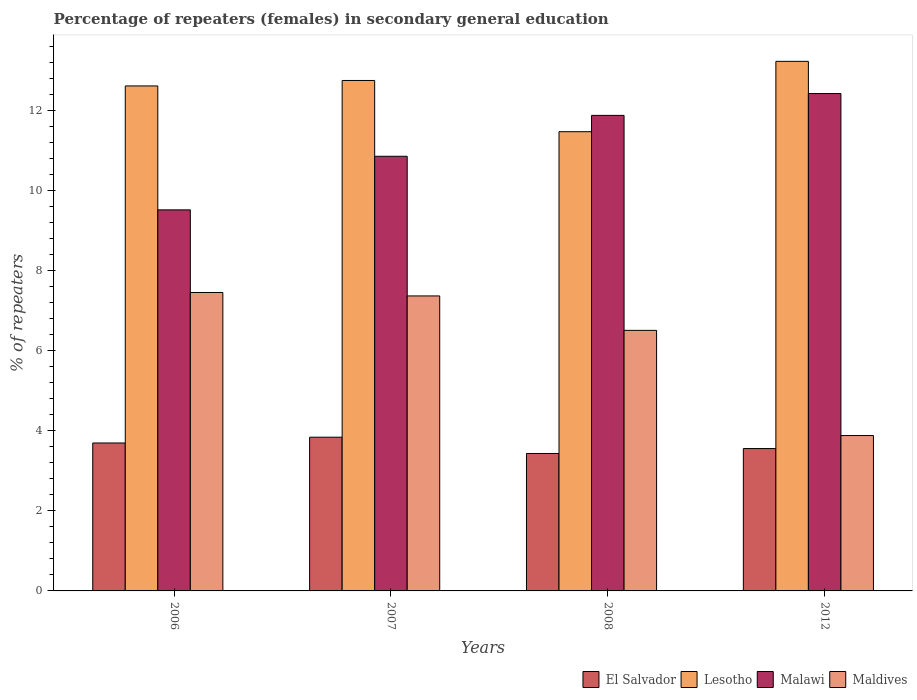How many different coloured bars are there?
Offer a very short reply. 4. How many bars are there on the 3rd tick from the left?
Make the answer very short. 4. How many bars are there on the 1st tick from the right?
Keep it short and to the point. 4. What is the label of the 2nd group of bars from the left?
Offer a very short reply. 2007. What is the percentage of female repeaters in Lesotho in 2012?
Give a very brief answer. 13.23. Across all years, what is the maximum percentage of female repeaters in El Salvador?
Provide a succinct answer. 3.84. Across all years, what is the minimum percentage of female repeaters in Malawi?
Ensure brevity in your answer.  9.52. In which year was the percentage of female repeaters in Lesotho maximum?
Offer a very short reply. 2012. In which year was the percentage of female repeaters in Maldives minimum?
Ensure brevity in your answer.  2012. What is the total percentage of female repeaters in Maldives in the graph?
Offer a very short reply. 25.23. What is the difference between the percentage of female repeaters in El Salvador in 2007 and that in 2012?
Your answer should be very brief. 0.28. What is the difference between the percentage of female repeaters in Lesotho in 2006 and the percentage of female repeaters in Maldives in 2012?
Offer a terse response. 8.74. What is the average percentage of female repeaters in Malawi per year?
Offer a very short reply. 11.18. In the year 2007, what is the difference between the percentage of female repeaters in Lesotho and percentage of female repeaters in El Salvador?
Offer a terse response. 8.91. In how many years, is the percentage of female repeaters in Lesotho greater than 0.8 %?
Provide a succinct answer. 4. What is the ratio of the percentage of female repeaters in Lesotho in 2006 to that in 2007?
Your response must be concise. 0.99. Is the difference between the percentage of female repeaters in Lesotho in 2006 and 2012 greater than the difference between the percentage of female repeaters in El Salvador in 2006 and 2012?
Offer a terse response. No. What is the difference between the highest and the second highest percentage of female repeaters in El Salvador?
Make the answer very short. 0.14. What is the difference between the highest and the lowest percentage of female repeaters in Lesotho?
Offer a very short reply. 1.76. In how many years, is the percentage of female repeaters in Lesotho greater than the average percentage of female repeaters in Lesotho taken over all years?
Ensure brevity in your answer.  3. Is it the case that in every year, the sum of the percentage of female repeaters in Maldives and percentage of female repeaters in El Salvador is greater than the sum of percentage of female repeaters in Lesotho and percentage of female repeaters in Malawi?
Your answer should be compact. Yes. What does the 3rd bar from the left in 2006 represents?
Provide a short and direct response. Malawi. What does the 2nd bar from the right in 2012 represents?
Ensure brevity in your answer.  Malawi. Is it the case that in every year, the sum of the percentage of female repeaters in Lesotho and percentage of female repeaters in Maldives is greater than the percentage of female repeaters in El Salvador?
Keep it short and to the point. Yes. How many years are there in the graph?
Keep it short and to the point. 4. Are the values on the major ticks of Y-axis written in scientific E-notation?
Offer a terse response. No. Does the graph contain any zero values?
Give a very brief answer. No. Where does the legend appear in the graph?
Your answer should be very brief. Bottom right. What is the title of the graph?
Provide a succinct answer. Percentage of repeaters (females) in secondary general education. What is the label or title of the Y-axis?
Keep it short and to the point. % of repeaters. What is the % of repeaters in El Salvador in 2006?
Make the answer very short. 3.7. What is the % of repeaters of Lesotho in 2006?
Make the answer very short. 12.62. What is the % of repeaters of Malawi in 2006?
Your answer should be compact. 9.52. What is the % of repeaters of Maldives in 2006?
Provide a short and direct response. 7.46. What is the % of repeaters in El Salvador in 2007?
Make the answer very short. 3.84. What is the % of repeaters in Lesotho in 2007?
Offer a very short reply. 12.76. What is the % of repeaters in Malawi in 2007?
Provide a short and direct response. 10.86. What is the % of repeaters of Maldives in 2007?
Give a very brief answer. 7.37. What is the % of repeaters in El Salvador in 2008?
Provide a short and direct response. 3.44. What is the % of repeaters in Lesotho in 2008?
Your answer should be compact. 11.48. What is the % of repeaters of Malawi in 2008?
Give a very brief answer. 11.88. What is the % of repeaters of Maldives in 2008?
Keep it short and to the point. 6.51. What is the % of repeaters in El Salvador in 2012?
Your answer should be compact. 3.56. What is the % of repeaters in Lesotho in 2012?
Ensure brevity in your answer.  13.23. What is the % of repeaters of Malawi in 2012?
Ensure brevity in your answer.  12.43. What is the % of repeaters of Maldives in 2012?
Your answer should be compact. 3.88. Across all years, what is the maximum % of repeaters of El Salvador?
Your answer should be compact. 3.84. Across all years, what is the maximum % of repeaters in Lesotho?
Provide a succinct answer. 13.23. Across all years, what is the maximum % of repeaters in Malawi?
Provide a succinct answer. 12.43. Across all years, what is the maximum % of repeaters of Maldives?
Give a very brief answer. 7.46. Across all years, what is the minimum % of repeaters of El Salvador?
Offer a terse response. 3.44. Across all years, what is the minimum % of repeaters in Lesotho?
Provide a succinct answer. 11.48. Across all years, what is the minimum % of repeaters of Malawi?
Provide a short and direct response. 9.52. Across all years, what is the minimum % of repeaters of Maldives?
Offer a very short reply. 3.88. What is the total % of repeaters of El Salvador in the graph?
Offer a very short reply. 14.53. What is the total % of repeaters in Lesotho in the graph?
Keep it short and to the point. 50.09. What is the total % of repeaters of Malawi in the graph?
Provide a succinct answer. 44.7. What is the total % of repeaters of Maldives in the graph?
Keep it short and to the point. 25.23. What is the difference between the % of repeaters in El Salvador in 2006 and that in 2007?
Give a very brief answer. -0.14. What is the difference between the % of repeaters in Lesotho in 2006 and that in 2007?
Offer a very short reply. -0.14. What is the difference between the % of repeaters of Malawi in 2006 and that in 2007?
Ensure brevity in your answer.  -1.34. What is the difference between the % of repeaters in Maldives in 2006 and that in 2007?
Provide a short and direct response. 0.09. What is the difference between the % of repeaters of El Salvador in 2006 and that in 2008?
Offer a terse response. 0.26. What is the difference between the % of repeaters of Lesotho in 2006 and that in 2008?
Make the answer very short. 1.14. What is the difference between the % of repeaters in Malawi in 2006 and that in 2008?
Give a very brief answer. -2.36. What is the difference between the % of repeaters in Maldives in 2006 and that in 2008?
Make the answer very short. 0.95. What is the difference between the % of repeaters of El Salvador in 2006 and that in 2012?
Your response must be concise. 0.14. What is the difference between the % of repeaters in Lesotho in 2006 and that in 2012?
Provide a short and direct response. -0.61. What is the difference between the % of repeaters of Malawi in 2006 and that in 2012?
Provide a succinct answer. -2.91. What is the difference between the % of repeaters of Maldives in 2006 and that in 2012?
Make the answer very short. 3.58. What is the difference between the % of repeaters in El Salvador in 2007 and that in 2008?
Offer a terse response. 0.41. What is the difference between the % of repeaters in Lesotho in 2007 and that in 2008?
Your answer should be very brief. 1.28. What is the difference between the % of repeaters of Malawi in 2007 and that in 2008?
Your response must be concise. -1.02. What is the difference between the % of repeaters in Maldives in 2007 and that in 2008?
Provide a short and direct response. 0.86. What is the difference between the % of repeaters in El Salvador in 2007 and that in 2012?
Your response must be concise. 0.28. What is the difference between the % of repeaters of Lesotho in 2007 and that in 2012?
Your answer should be compact. -0.48. What is the difference between the % of repeaters in Malawi in 2007 and that in 2012?
Your answer should be compact. -1.57. What is the difference between the % of repeaters in Maldives in 2007 and that in 2012?
Offer a terse response. 3.49. What is the difference between the % of repeaters in El Salvador in 2008 and that in 2012?
Provide a short and direct response. -0.12. What is the difference between the % of repeaters in Lesotho in 2008 and that in 2012?
Give a very brief answer. -1.76. What is the difference between the % of repeaters in Malawi in 2008 and that in 2012?
Offer a very short reply. -0.55. What is the difference between the % of repeaters of Maldives in 2008 and that in 2012?
Your answer should be compact. 2.63. What is the difference between the % of repeaters of El Salvador in 2006 and the % of repeaters of Lesotho in 2007?
Your answer should be very brief. -9.06. What is the difference between the % of repeaters of El Salvador in 2006 and the % of repeaters of Malawi in 2007?
Your response must be concise. -7.17. What is the difference between the % of repeaters in El Salvador in 2006 and the % of repeaters in Maldives in 2007?
Give a very brief answer. -3.67. What is the difference between the % of repeaters of Lesotho in 2006 and the % of repeaters of Malawi in 2007?
Offer a very short reply. 1.76. What is the difference between the % of repeaters of Lesotho in 2006 and the % of repeaters of Maldives in 2007?
Keep it short and to the point. 5.25. What is the difference between the % of repeaters in Malawi in 2006 and the % of repeaters in Maldives in 2007?
Your answer should be compact. 2.15. What is the difference between the % of repeaters of El Salvador in 2006 and the % of repeaters of Lesotho in 2008?
Ensure brevity in your answer.  -7.78. What is the difference between the % of repeaters in El Salvador in 2006 and the % of repeaters in Malawi in 2008?
Ensure brevity in your answer.  -8.19. What is the difference between the % of repeaters in El Salvador in 2006 and the % of repeaters in Maldives in 2008?
Your answer should be very brief. -2.81. What is the difference between the % of repeaters in Lesotho in 2006 and the % of repeaters in Malawi in 2008?
Offer a very short reply. 0.74. What is the difference between the % of repeaters in Lesotho in 2006 and the % of repeaters in Maldives in 2008?
Provide a succinct answer. 6.11. What is the difference between the % of repeaters in Malawi in 2006 and the % of repeaters in Maldives in 2008?
Provide a short and direct response. 3.01. What is the difference between the % of repeaters in El Salvador in 2006 and the % of repeaters in Lesotho in 2012?
Your answer should be very brief. -9.54. What is the difference between the % of repeaters in El Salvador in 2006 and the % of repeaters in Malawi in 2012?
Provide a short and direct response. -8.73. What is the difference between the % of repeaters of El Salvador in 2006 and the % of repeaters of Maldives in 2012?
Offer a terse response. -0.19. What is the difference between the % of repeaters in Lesotho in 2006 and the % of repeaters in Malawi in 2012?
Your response must be concise. 0.19. What is the difference between the % of repeaters of Lesotho in 2006 and the % of repeaters of Maldives in 2012?
Provide a succinct answer. 8.74. What is the difference between the % of repeaters in Malawi in 2006 and the % of repeaters in Maldives in 2012?
Your answer should be compact. 5.64. What is the difference between the % of repeaters of El Salvador in 2007 and the % of repeaters of Lesotho in 2008?
Your response must be concise. -7.63. What is the difference between the % of repeaters in El Salvador in 2007 and the % of repeaters in Malawi in 2008?
Make the answer very short. -8.04. What is the difference between the % of repeaters in El Salvador in 2007 and the % of repeaters in Maldives in 2008?
Your answer should be very brief. -2.67. What is the difference between the % of repeaters in Lesotho in 2007 and the % of repeaters in Malawi in 2008?
Keep it short and to the point. 0.87. What is the difference between the % of repeaters in Lesotho in 2007 and the % of repeaters in Maldives in 2008?
Keep it short and to the point. 6.25. What is the difference between the % of repeaters of Malawi in 2007 and the % of repeaters of Maldives in 2008?
Ensure brevity in your answer.  4.35. What is the difference between the % of repeaters in El Salvador in 2007 and the % of repeaters in Lesotho in 2012?
Your answer should be very brief. -9.39. What is the difference between the % of repeaters in El Salvador in 2007 and the % of repeaters in Malawi in 2012?
Keep it short and to the point. -8.59. What is the difference between the % of repeaters in El Salvador in 2007 and the % of repeaters in Maldives in 2012?
Give a very brief answer. -0.04. What is the difference between the % of repeaters of Lesotho in 2007 and the % of repeaters of Malawi in 2012?
Your answer should be compact. 0.33. What is the difference between the % of repeaters of Lesotho in 2007 and the % of repeaters of Maldives in 2012?
Give a very brief answer. 8.87. What is the difference between the % of repeaters in Malawi in 2007 and the % of repeaters in Maldives in 2012?
Provide a succinct answer. 6.98. What is the difference between the % of repeaters of El Salvador in 2008 and the % of repeaters of Lesotho in 2012?
Provide a short and direct response. -9.8. What is the difference between the % of repeaters in El Salvador in 2008 and the % of repeaters in Malawi in 2012?
Your answer should be compact. -9. What is the difference between the % of repeaters in El Salvador in 2008 and the % of repeaters in Maldives in 2012?
Your answer should be compact. -0.45. What is the difference between the % of repeaters in Lesotho in 2008 and the % of repeaters in Malawi in 2012?
Give a very brief answer. -0.95. What is the difference between the % of repeaters of Lesotho in 2008 and the % of repeaters of Maldives in 2012?
Ensure brevity in your answer.  7.59. What is the difference between the % of repeaters in Malawi in 2008 and the % of repeaters in Maldives in 2012?
Offer a terse response. 8. What is the average % of repeaters of El Salvador per year?
Ensure brevity in your answer.  3.63. What is the average % of repeaters in Lesotho per year?
Offer a very short reply. 12.52. What is the average % of repeaters of Malawi per year?
Provide a succinct answer. 11.18. What is the average % of repeaters of Maldives per year?
Provide a short and direct response. 6.31. In the year 2006, what is the difference between the % of repeaters in El Salvador and % of repeaters in Lesotho?
Your answer should be compact. -8.92. In the year 2006, what is the difference between the % of repeaters in El Salvador and % of repeaters in Malawi?
Your answer should be very brief. -5.83. In the year 2006, what is the difference between the % of repeaters of El Salvador and % of repeaters of Maldives?
Your response must be concise. -3.76. In the year 2006, what is the difference between the % of repeaters in Lesotho and % of repeaters in Malawi?
Offer a terse response. 3.1. In the year 2006, what is the difference between the % of repeaters in Lesotho and % of repeaters in Maldives?
Give a very brief answer. 5.16. In the year 2006, what is the difference between the % of repeaters of Malawi and % of repeaters of Maldives?
Your answer should be very brief. 2.06. In the year 2007, what is the difference between the % of repeaters of El Salvador and % of repeaters of Lesotho?
Your response must be concise. -8.91. In the year 2007, what is the difference between the % of repeaters in El Salvador and % of repeaters in Malawi?
Provide a short and direct response. -7.02. In the year 2007, what is the difference between the % of repeaters of El Salvador and % of repeaters of Maldives?
Make the answer very short. -3.53. In the year 2007, what is the difference between the % of repeaters in Lesotho and % of repeaters in Malawi?
Your response must be concise. 1.89. In the year 2007, what is the difference between the % of repeaters of Lesotho and % of repeaters of Maldives?
Ensure brevity in your answer.  5.38. In the year 2007, what is the difference between the % of repeaters of Malawi and % of repeaters of Maldives?
Your response must be concise. 3.49. In the year 2008, what is the difference between the % of repeaters in El Salvador and % of repeaters in Lesotho?
Offer a terse response. -8.04. In the year 2008, what is the difference between the % of repeaters in El Salvador and % of repeaters in Malawi?
Keep it short and to the point. -8.45. In the year 2008, what is the difference between the % of repeaters of El Salvador and % of repeaters of Maldives?
Your answer should be very brief. -3.08. In the year 2008, what is the difference between the % of repeaters in Lesotho and % of repeaters in Malawi?
Keep it short and to the point. -0.41. In the year 2008, what is the difference between the % of repeaters in Lesotho and % of repeaters in Maldives?
Offer a terse response. 4.97. In the year 2008, what is the difference between the % of repeaters in Malawi and % of repeaters in Maldives?
Your response must be concise. 5.37. In the year 2012, what is the difference between the % of repeaters in El Salvador and % of repeaters in Lesotho?
Your answer should be very brief. -9.68. In the year 2012, what is the difference between the % of repeaters of El Salvador and % of repeaters of Malawi?
Make the answer very short. -8.87. In the year 2012, what is the difference between the % of repeaters of El Salvador and % of repeaters of Maldives?
Keep it short and to the point. -0.33. In the year 2012, what is the difference between the % of repeaters of Lesotho and % of repeaters of Malawi?
Ensure brevity in your answer.  0.8. In the year 2012, what is the difference between the % of repeaters of Lesotho and % of repeaters of Maldives?
Your answer should be very brief. 9.35. In the year 2012, what is the difference between the % of repeaters of Malawi and % of repeaters of Maldives?
Your response must be concise. 8.55. What is the ratio of the % of repeaters in El Salvador in 2006 to that in 2007?
Keep it short and to the point. 0.96. What is the ratio of the % of repeaters in Lesotho in 2006 to that in 2007?
Provide a succinct answer. 0.99. What is the ratio of the % of repeaters in Malawi in 2006 to that in 2007?
Give a very brief answer. 0.88. What is the ratio of the % of repeaters of Maldives in 2006 to that in 2007?
Provide a short and direct response. 1.01. What is the ratio of the % of repeaters of El Salvador in 2006 to that in 2008?
Your answer should be compact. 1.08. What is the ratio of the % of repeaters of Lesotho in 2006 to that in 2008?
Provide a succinct answer. 1.1. What is the ratio of the % of repeaters of Malawi in 2006 to that in 2008?
Make the answer very short. 0.8. What is the ratio of the % of repeaters in Maldives in 2006 to that in 2008?
Your answer should be compact. 1.15. What is the ratio of the % of repeaters of El Salvador in 2006 to that in 2012?
Ensure brevity in your answer.  1.04. What is the ratio of the % of repeaters in Lesotho in 2006 to that in 2012?
Your answer should be compact. 0.95. What is the ratio of the % of repeaters of Malawi in 2006 to that in 2012?
Your response must be concise. 0.77. What is the ratio of the % of repeaters of Maldives in 2006 to that in 2012?
Provide a succinct answer. 1.92. What is the ratio of the % of repeaters of El Salvador in 2007 to that in 2008?
Offer a terse response. 1.12. What is the ratio of the % of repeaters of Lesotho in 2007 to that in 2008?
Make the answer very short. 1.11. What is the ratio of the % of repeaters of Malawi in 2007 to that in 2008?
Keep it short and to the point. 0.91. What is the ratio of the % of repeaters in Maldives in 2007 to that in 2008?
Offer a terse response. 1.13. What is the ratio of the % of repeaters of El Salvador in 2007 to that in 2012?
Ensure brevity in your answer.  1.08. What is the ratio of the % of repeaters of Lesotho in 2007 to that in 2012?
Ensure brevity in your answer.  0.96. What is the ratio of the % of repeaters in Malawi in 2007 to that in 2012?
Provide a short and direct response. 0.87. What is the ratio of the % of repeaters in Maldives in 2007 to that in 2012?
Provide a succinct answer. 1.9. What is the ratio of the % of repeaters in El Salvador in 2008 to that in 2012?
Keep it short and to the point. 0.97. What is the ratio of the % of repeaters of Lesotho in 2008 to that in 2012?
Make the answer very short. 0.87. What is the ratio of the % of repeaters of Malawi in 2008 to that in 2012?
Ensure brevity in your answer.  0.96. What is the ratio of the % of repeaters in Maldives in 2008 to that in 2012?
Your answer should be very brief. 1.68. What is the difference between the highest and the second highest % of repeaters of El Salvador?
Your answer should be compact. 0.14. What is the difference between the highest and the second highest % of repeaters of Lesotho?
Ensure brevity in your answer.  0.48. What is the difference between the highest and the second highest % of repeaters of Malawi?
Provide a succinct answer. 0.55. What is the difference between the highest and the second highest % of repeaters of Maldives?
Make the answer very short. 0.09. What is the difference between the highest and the lowest % of repeaters in El Salvador?
Make the answer very short. 0.41. What is the difference between the highest and the lowest % of repeaters in Lesotho?
Ensure brevity in your answer.  1.76. What is the difference between the highest and the lowest % of repeaters of Malawi?
Your answer should be very brief. 2.91. What is the difference between the highest and the lowest % of repeaters in Maldives?
Your answer should be very brief. 3.58. 